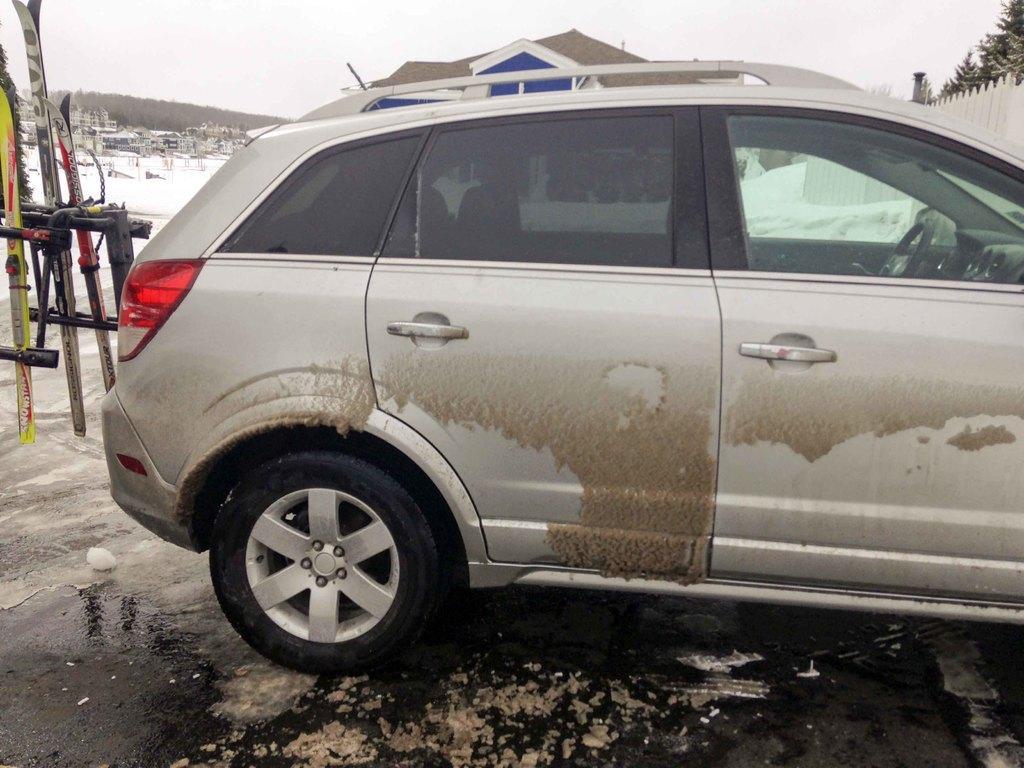How would you summarize this image in a sentence or two? In the center of the image there is a car. On the right there is a fence and trees. On the left there are boards. In the background there is a hill, snow and sky. 